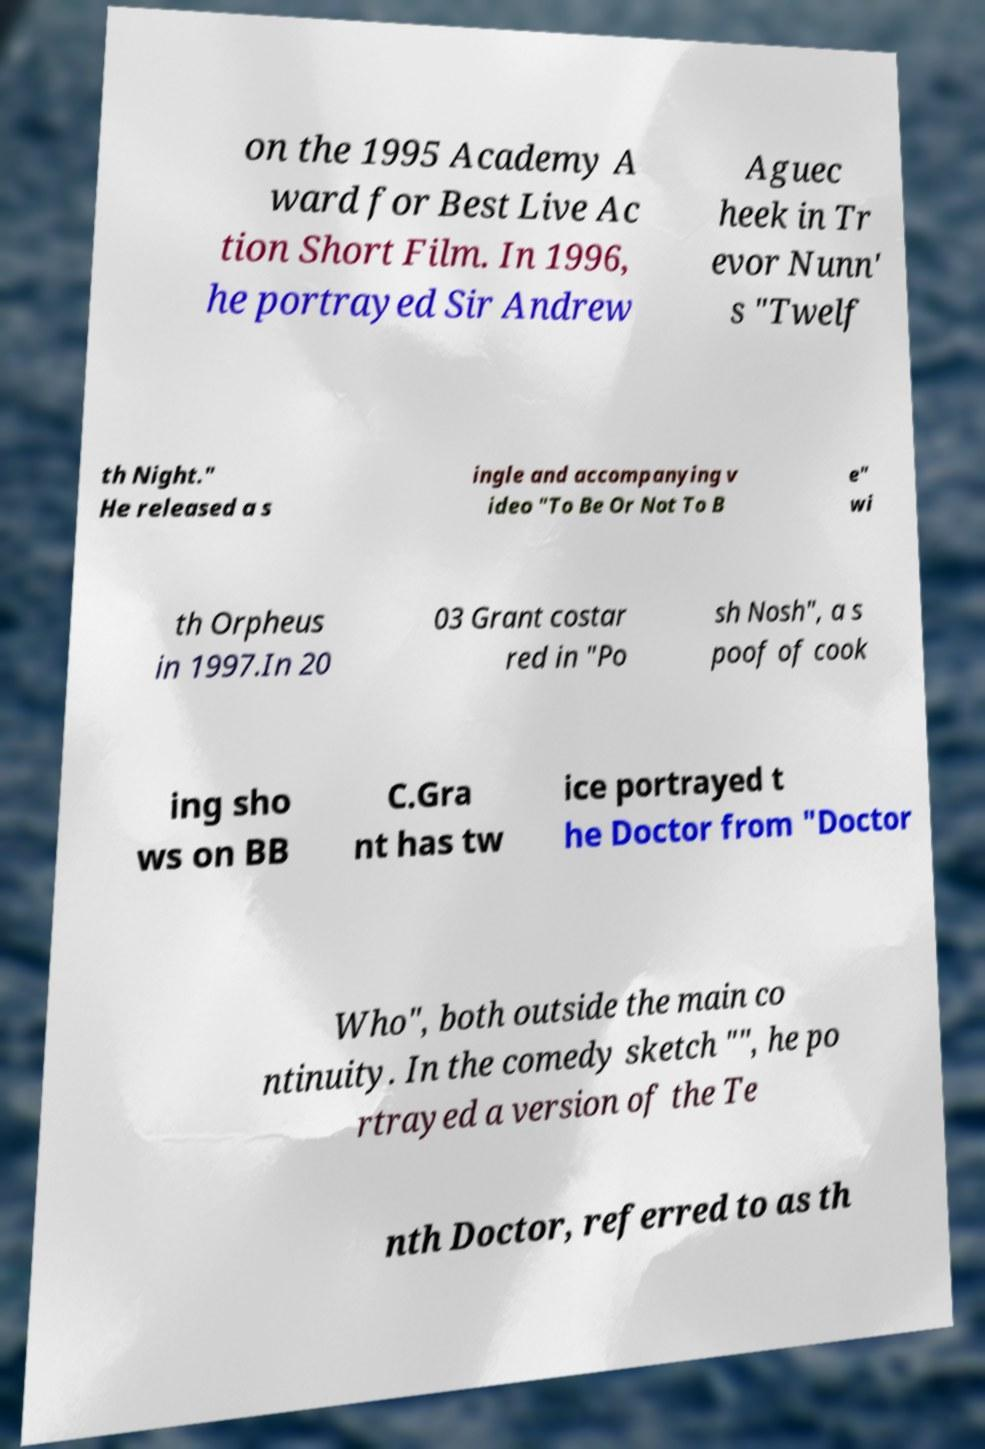Can you read and provide the text displayed in the image?This photo seems to have some interesting text. Can you extract and type it out for me? on the 1995 Academy A ward for Best Live Ac tion Short Film. In 1996, he portrayed Sir Andrew Aguec heek in Tr evor Nunn' s "Twelf th Night." He released a s ingle and accompanying v ideo "To Be Or Not To B e" wi th Orpheus in 1997.In 20 03 Grant costar red in "Po sh Nosh", a s poof of cook ing sho ws on BB C.Gra nt has tw ice portrayed t he Doctor from "Doctor Who", both outside the main co ntinuity. In the comedy sketch "", he po rtrayed a version of the Te nth Doctor, referred to as th 